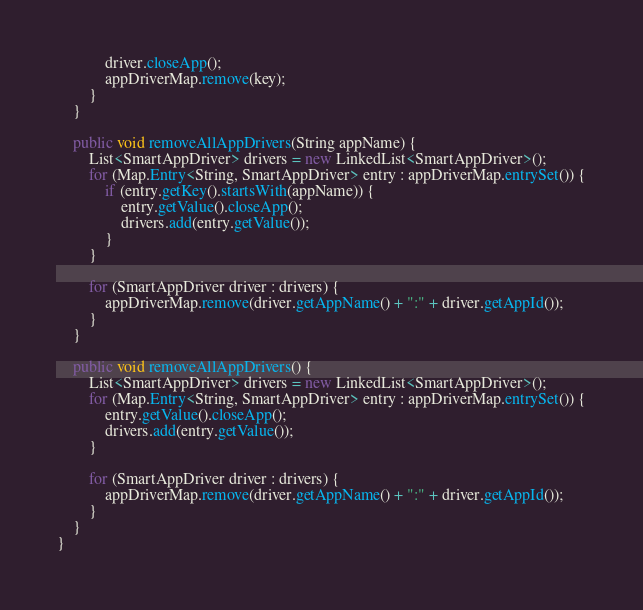Convert code to text. <code><loc_0><loc_0><loc_500><loc_500><_Java_>			driver.closeApp();
			appDriverMap.remove(key);
		}
	}

	public void removeAllAppDrivers(String appName) {
		List<SmartAppDriver> drivers = new LinkedList<SmartAppDriver>();
		for (Map.Entry<String, SmartAppDriver> entry : appDriverMap.entrySet()) {
			if (entry.getKey().startsWith(appName)) {
				entry.getValue().closeApp();
				drivers.add(entry.getValue());
			}
		}

		for (SmartAppDriver driver : drivers) {
			appDriverMap.remove(driver.getAppName() + ":" + driver.getAppId());
		}
	}

	public void removeAllAppDrivers() {
		List<SmartAppDriver> drivers = new LinkedList<SmartAppDriver>();
		for (Map.Entry<String, SmartAppDriver> entry : appDriverMap.entrySet()) {
			entry.getValue().closeApp();
			drivers.add(entry.getValue());
		}

		for (SmartAppDriver driver : drivers) {
			appDriverMap.remove(driver.getAppName() + ":" + driver.getAppId());
		}
	}
}
</code> 